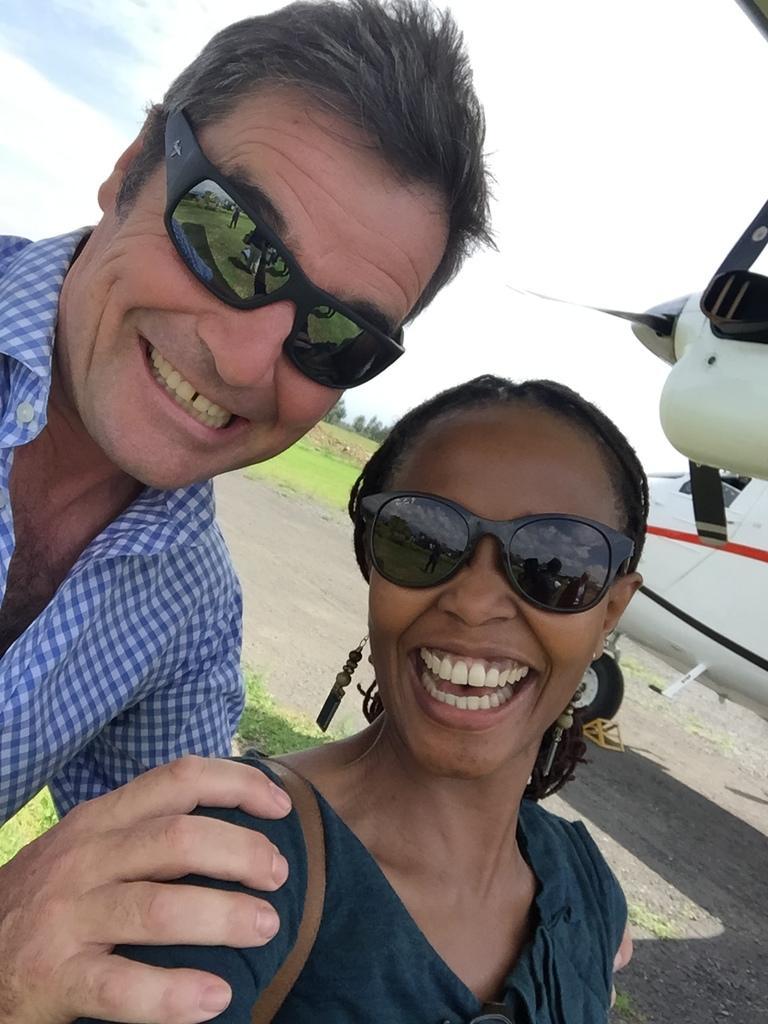Please provide a concise description of this image. In this picture we can see two people wore goggles, smiling and in the background we can see an airplane on the ground, grass, trees and the sky. 